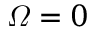Convert formula to latex. <formula><loc_0><loc_0><loc_500><loc_500>\varOmega = 0</formula> 